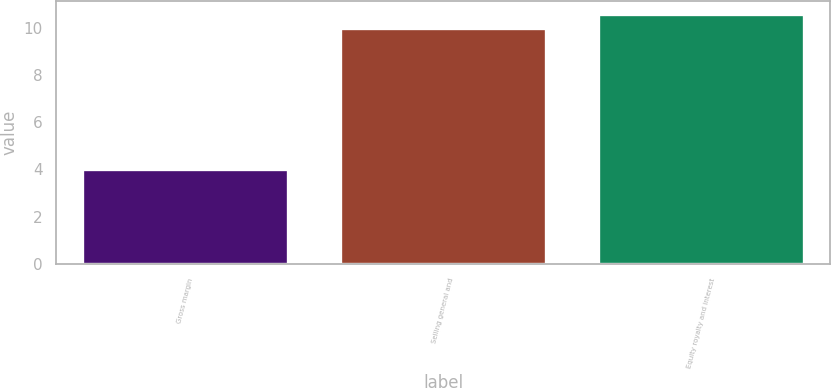Convert chart. <chart><loc_0><loc_0><loc_500><loc_500><bar_chart><fcel>Gross margin<fcel>Selling general and<fcel>Equity royalty and interest<nl><fcel>4<fcel>10<fcel>10.6<nl></chart> 